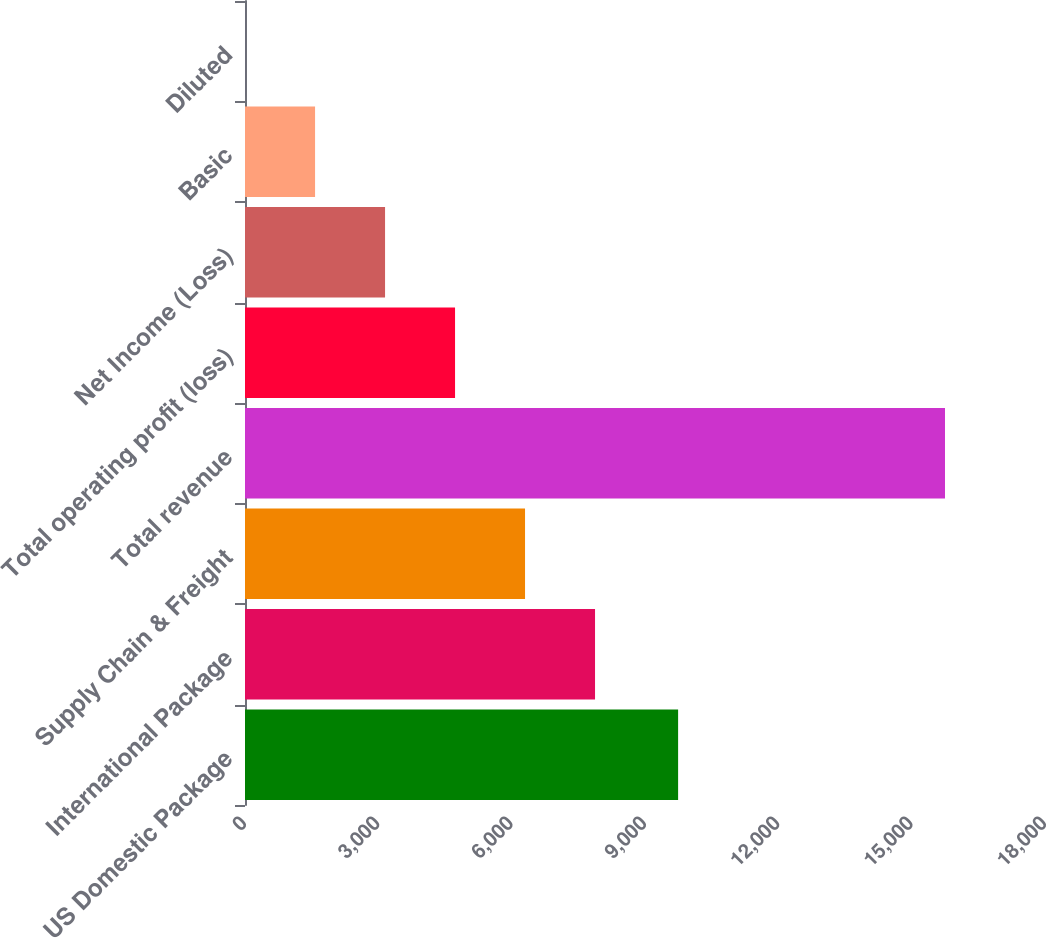Convert chart. <chart><loc_0><loc_0><loc_500><loc_500><bar_chart><fcel>US Domestic Package<fcel>International Package<fcel>Supply Chain & Freight<fcel>Total revenue<fcel>Total operating profit (loss)<fcel>Net Income (Loss)<fcel>Basic<fcel>Diluted<nl><fcel>9745<fcel>7875.78<fcel>6300.94<fcel>15750<fcel>4726.1<fcel>3151.26<fcel>1576.42<fcel>1.58<nl></chart> 